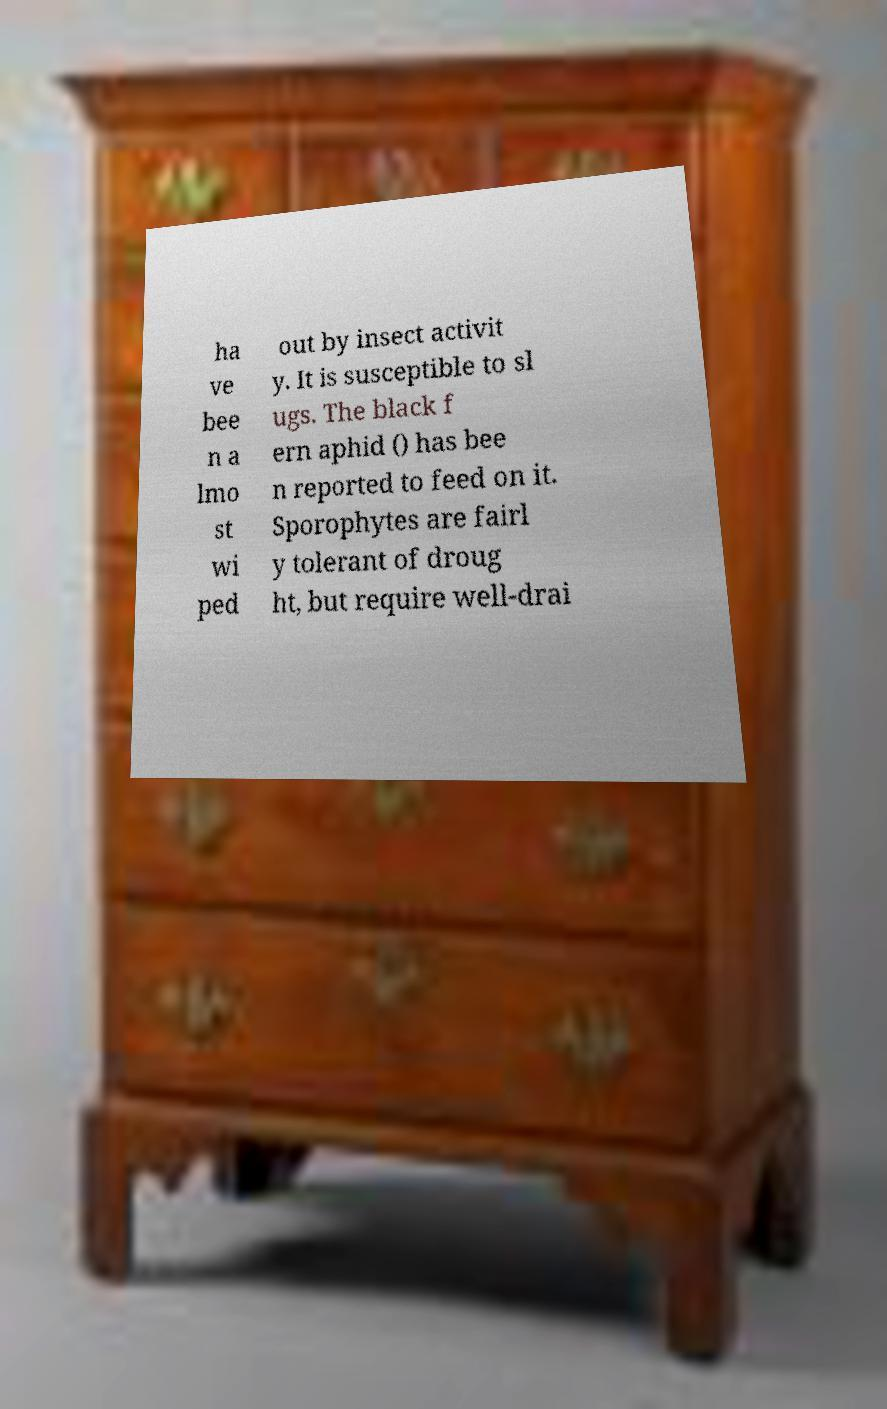There's text embedded in this image that I need extracted. Can you transcribe it verbatim? ha ve bee n a lmo st wi ped out by insect activit y. It is susceptible to sl ugs. The black f ern aphid () has bee n reported to feed on it. Sporophytes are fairl y tolerant of droug ht, but require well-drai 